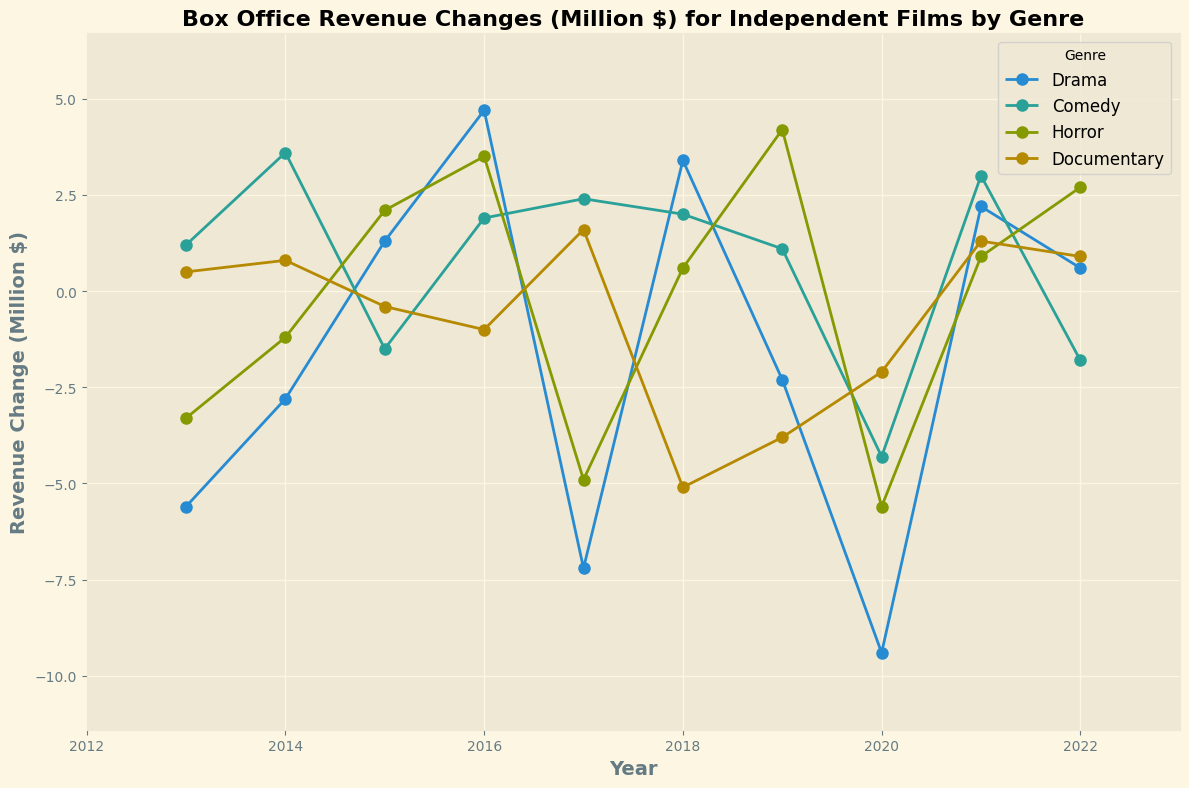What is the box office revenue change for independent horror films in 2020? Look at the data point corresponding to the genre 'Horror' for the year 2020 on the plot. The revenue for horror films in 2020 is -5.6 million dollars.
Answer: -5.6 million dollars Which genre had the highest positive box office revenue change in 2021? Observe the different lines plotted for each genre and check which has the highest value for the year 2021. Comedy has the highest positive change with a value of 3.0 million dollars.
Answer: Comedy What is the average box office revenue change for Drama films from 2013 to 2022? List the revenue changes for Drama films ([-5.6, -2.8, 1.3, 4.7, -7.2, 3.4, -2.3, -9.4, 2.2, 0.6]) and calculate the mean: (-5.6-2.8+1.3+4.7-7.2+3.4-2.3-9.4+2.2+0.6)/10 = -1.51.
Answer: -1.51 million dollars In which year did documentary films experience the largest negative box office revenue change? Look for the genre 'Documentary' and identify the point with the largest negative change. The largest negative change is in 2018 with -5.1 million dollars.
Answer: 2018 Compare the box office revenue change of Comedy and Drama films in 2015. Which had a higher change and by how much? Check the revenue changes for Comedy (1.5) and Drama (1.3) in 2015 on the plot. Comedy had a higher change by (1.3-(-1.5)) = 2.8 million dollars.
Answer: Comedy, by 2.8 million dollars What is the overall trend in box office revenue change for Horror films over the decade? Examine the line representing Horror films from 2013 to 2022. The line shows fluctuations, but a generally upward trend is visible after a drop in 2015 and 2016, followed by another large drop in 2020.
Answer: Generally upward with fluctuations Which genre had the smallest change in revenue in 2020 and what was the value? Check all genres for the year 2020 and find the smallest absolute value without regard to sign. Documentary had the smallest revenue change of -2.1 million dollars.
Answer: Documentary, -2.1 million dollars Between 2014 and 2015, which genre showed the most significant improvement or decline? Compute the difference in revenue for each genre between 2014 and 2015 and identify the largest absolute change. Horror improved the most by changing from -1.2 million dollars in 2014 to 2.1 million dollars in 2015: a change of 3.3 million dollars.
Answer: Horror, improved by 3.3 million dollars Was there any year in which all genres experienced a negative revenue change? Identify the years where all plotted genres have negative values. This happens in 2020 where Drama (-9.4), Comedy (-4.3), Horror (-5.6), and Documentary (-2.1) all show negative changes.
Answer: 2020 What was the total box office revenue change across all genres in 2017? Sum the revenue changes for all genres in 2017: Drama (-7.2), Comedy (2.4), Horror (-4.9), Documentary (1.6). The total sum is -7.2 + 2.4 - 4.9 + 1.6 = -8.1.
Answer: -8.1 million dollars 